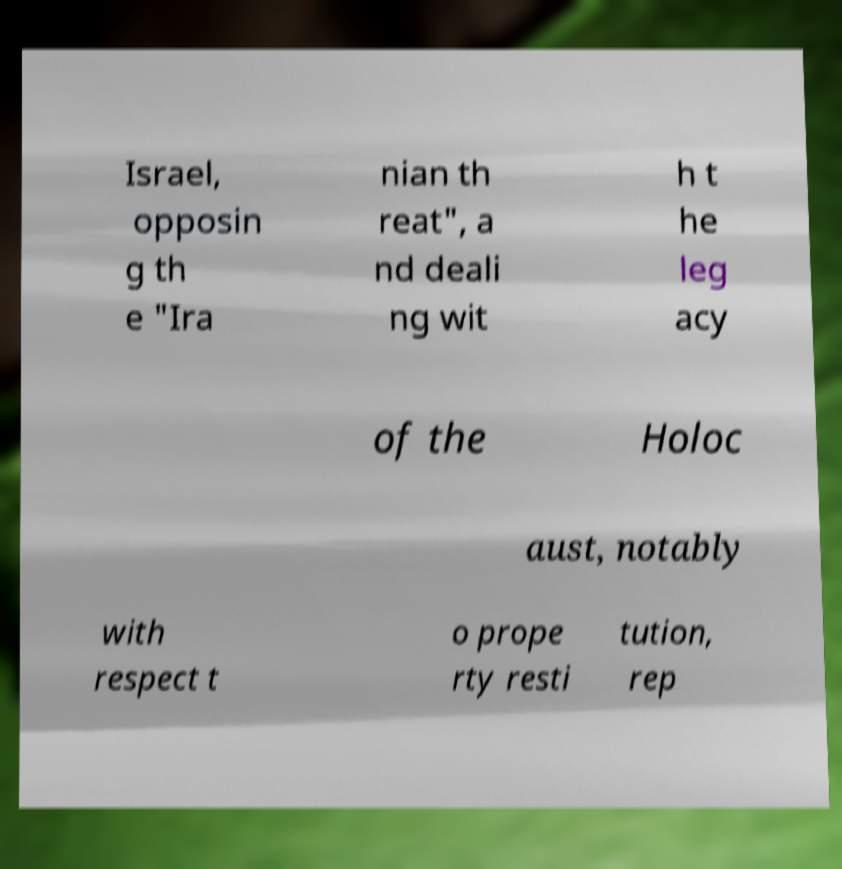Can you read and provide the text displayed in the image?This photo seems to have some interesting text. Can you extract and type it out for me? Israel, opposin g th e "Ira nian th reat", a nd deali ng wit h t he leg acy of the Holoc aust, notably with respect t o prope rty resti tution, rep 